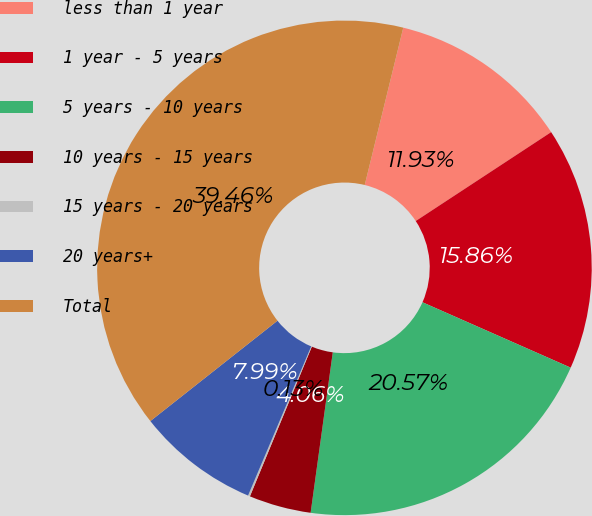Convert chart. <chart><loc_0><loc_0><loc_500><loc_500><pie_chart><fcel>less than 1 year<fcel>1 year - 5 years<fcel>5 years - 10 years<fcel>10 years - 15 years<fcel>15 years - 20 years<fcel>20 years+<fcel>Total<nl><fcel>11.93%<fcel>15.86%<fcel>20.57%<fcel>4.06%<fcel>0.13%<fcel>7.99%<fcel>39.46%<nl></chart> 